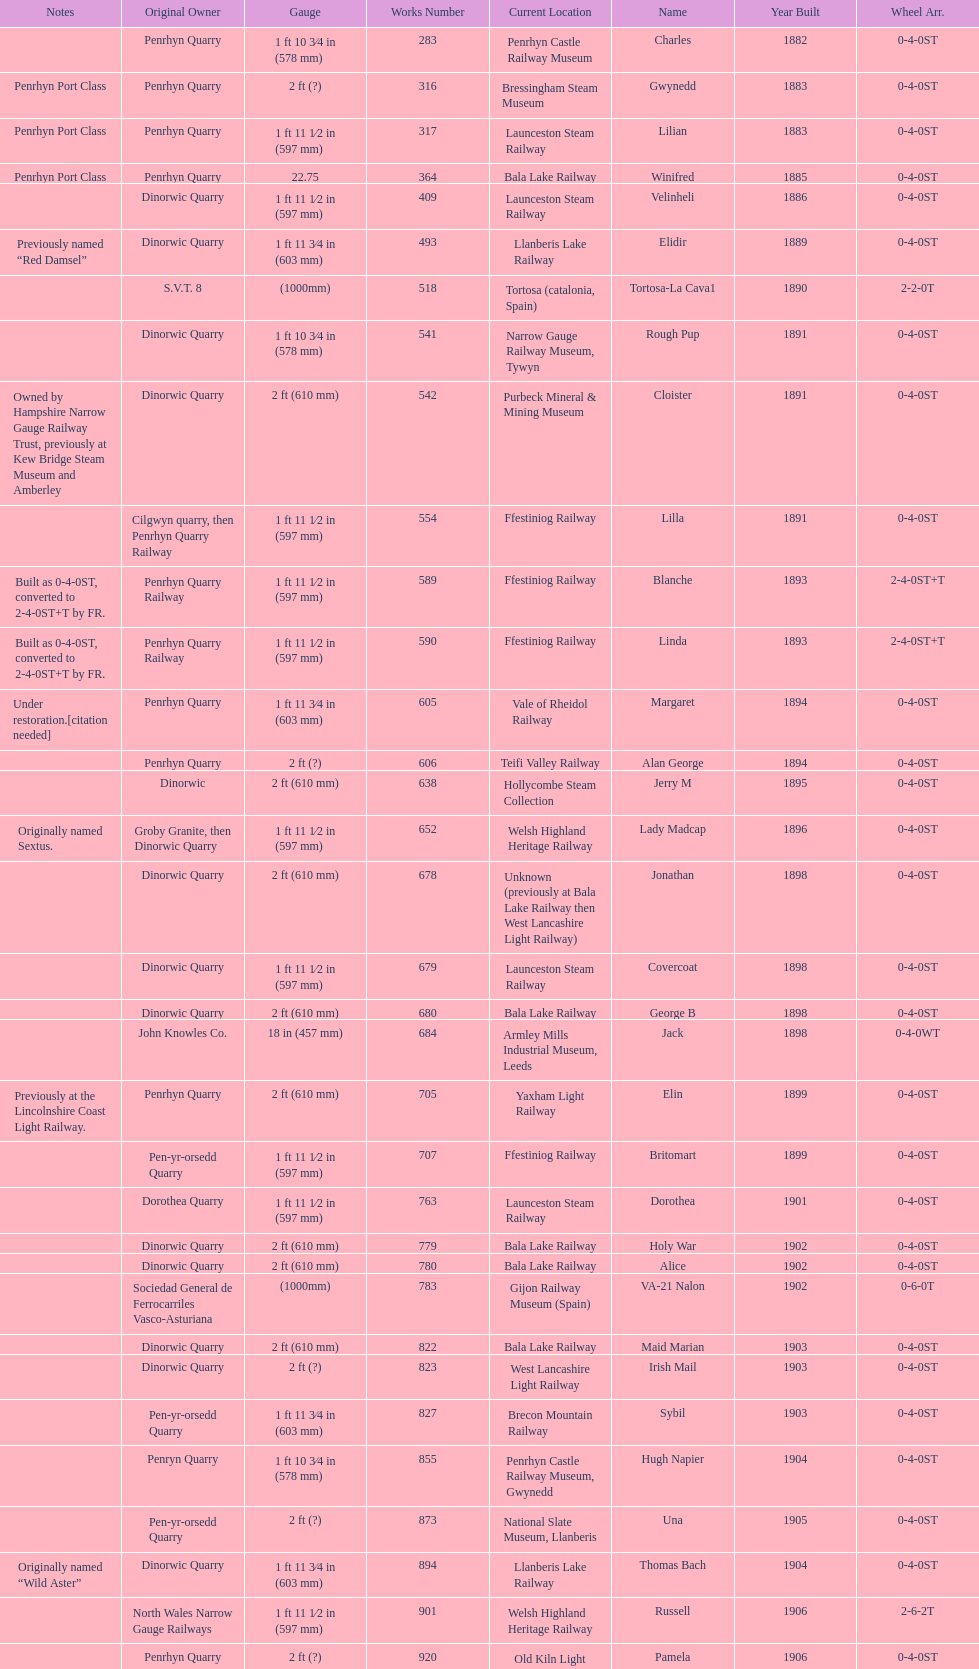What is the total number of preserved hunslet narrow gauge locomotives currently located in ffestiniog railway 554. 